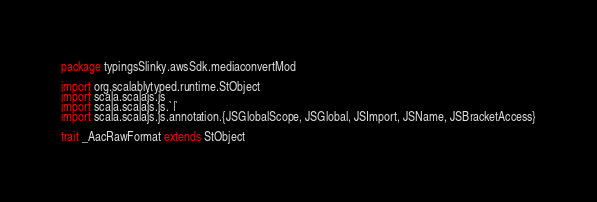<code> <loc_0><loc_0><loc_500><loc_500><_Scala_>package typingsSlinky.awsSdk.mediaconvertMod

import org.scalablytyped.runtime.StObject
import scala.scalajs.js
import scala.scalajs.js.`|`
import scala.scalajs.js.annotation.{JSGlobalScope, JSGlobal, JSImport, JSName, JSBracketAccess}

trait _AacRawFormat extends StObject
</code> 